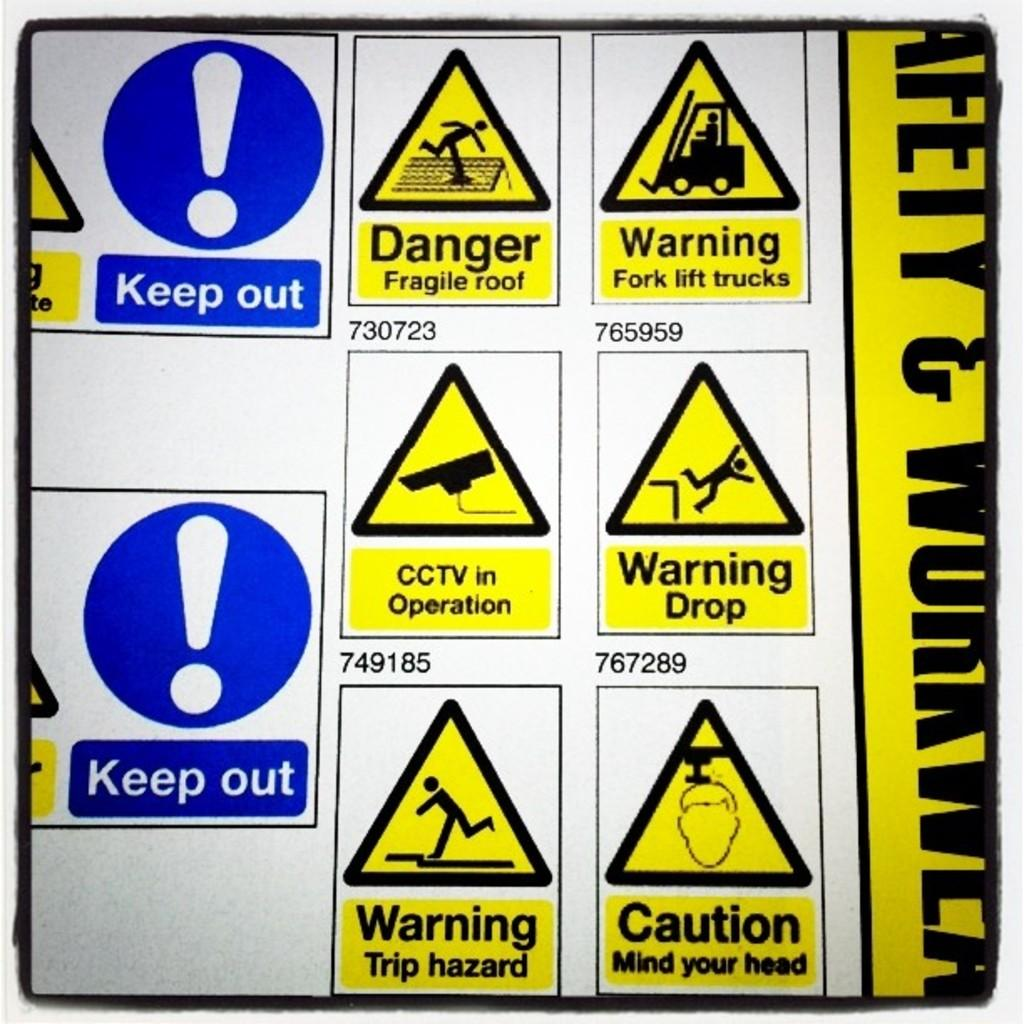<image>
Create a compact narrative representing the image presented. six yellow triangles with danger and warnings signs and two blu Keep out sign with cicrcle shape and exclamation  sign 